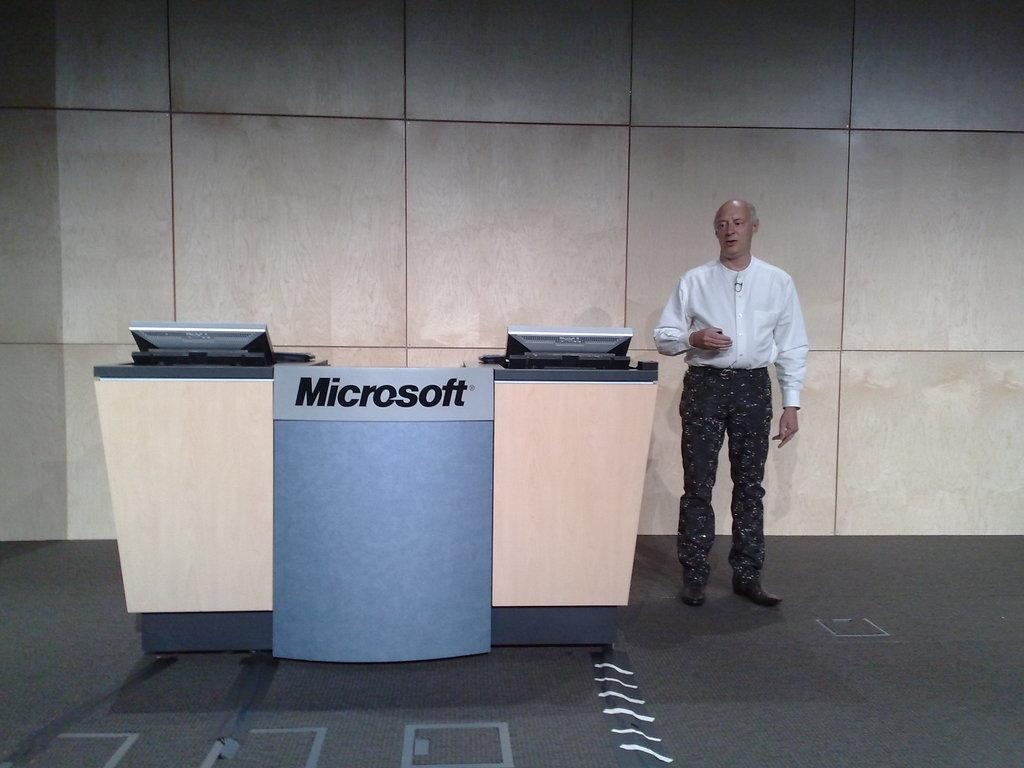<image>
Write a terse but informative summary of the picture. A man is standing by the Microsoft products booth. 